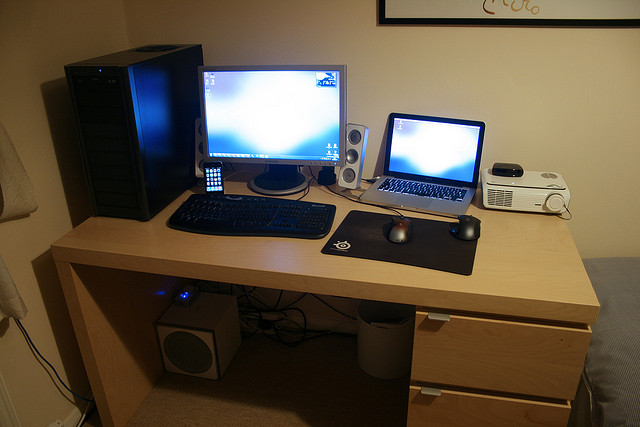<image>What color is the wastebasket? There is no wastebasket in the image. However, it could be white, black, or brown. What color is the wastebasket? It is unknown what color the wastebasket is. It can be white, black, brown or nonexistent. 